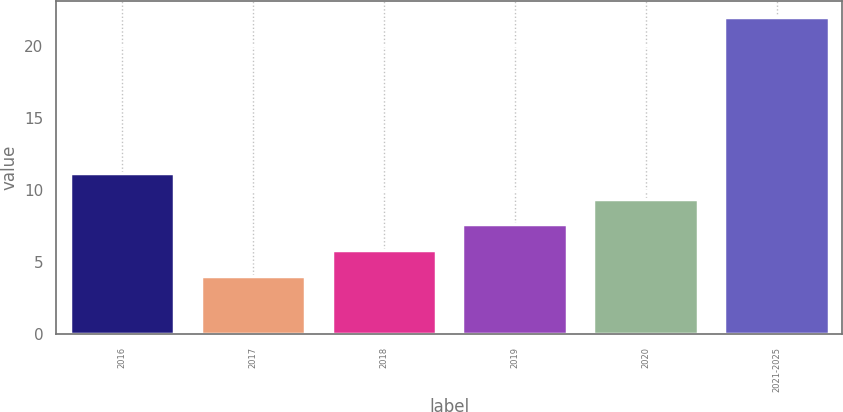<chart> <loc_0><loc_0><loc_500><loc_500><bar_chart><fcel>2016<fcel>2017<fcel>2018<fcel>2019<fcel>2020<fcel>2021-2025<nl><fcel>11.2<fcel>4<fcel>5.8<fcel>7.6<fcel>9.4<fcel>22<nl></chart> 